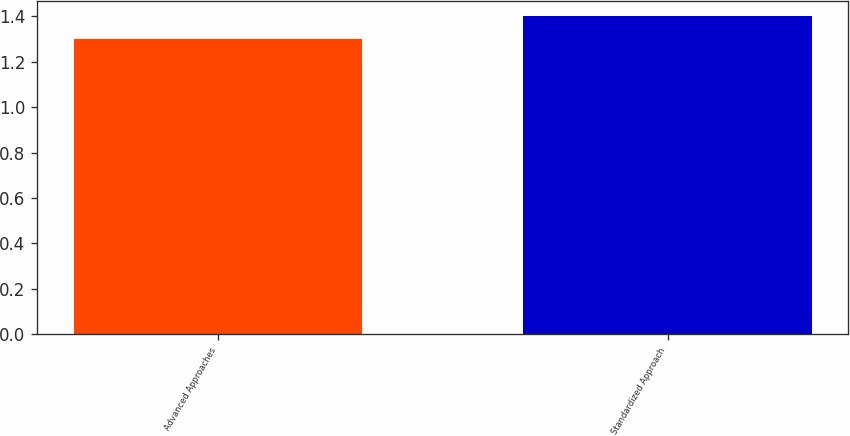Convert chart. <chart><loc_0><loc_0><loc_500><loc_500><bar_chart><fcel>Advanced Approaches<fcel>Standardized Approach<nl><fcel>1.3<fcel>1.4<nl></chart> 